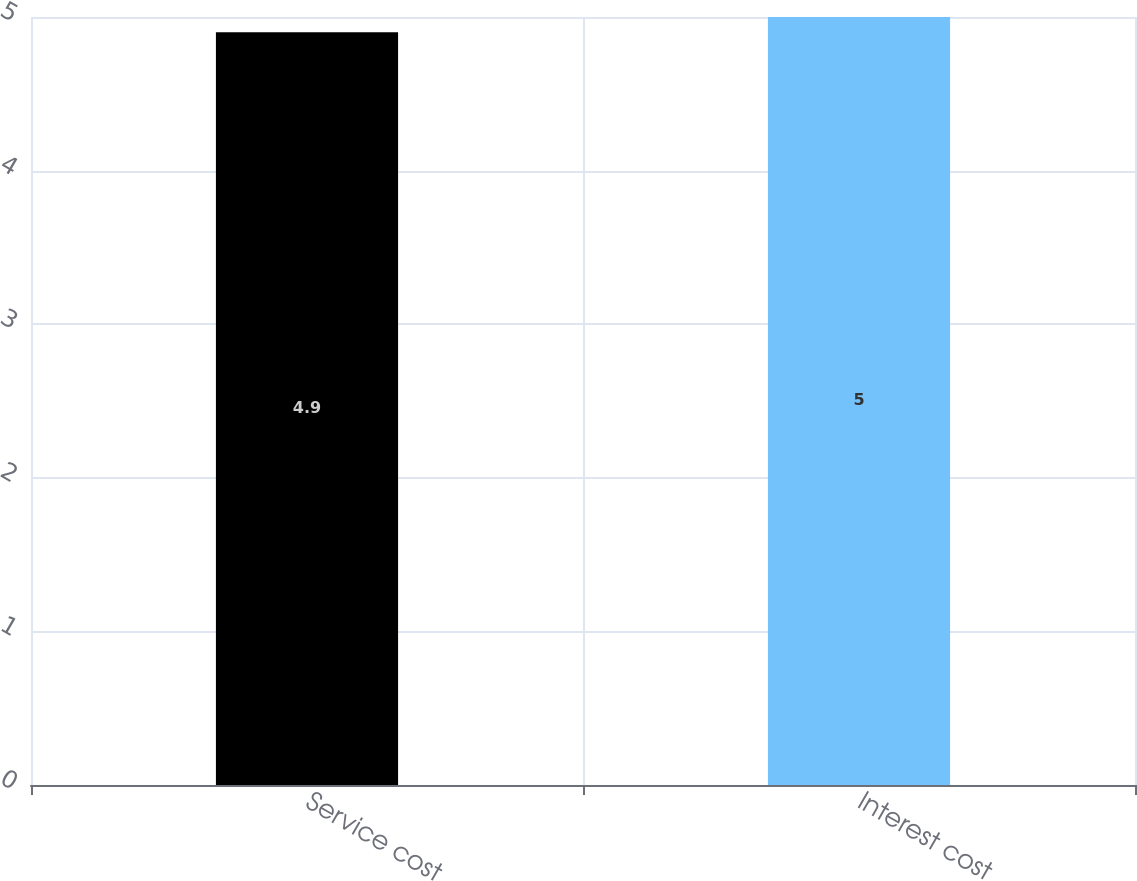Convert chart. <chart><loc_0><loc_0><loc_500><loc_500><bar_chart><fcel>Service cost<fcel>Interest cost<nl><fcel>4.9<fcel>5<nl></chart> 